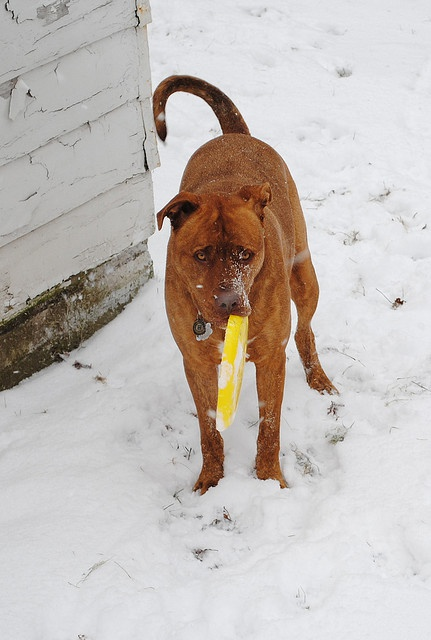Describe the objects in this image and their specific colors. I can see dog in darkgray, brown, maroon, and gray tones and frisbee in darkgray, gold, tan, khaki, and lightgray tones in this image. 